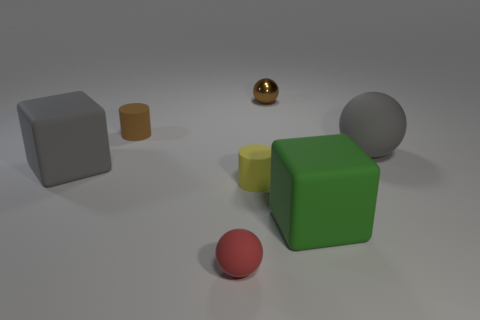Are there any other things that are made of the same material as the brown sphere?
Offer a very short reply. No. There is a tiny thing that is both behind the yellow rubber cylinder and on the right side of the brown cylinder; what material is it?
Your answer should be very brief. Metal. Is the color of the rubber block left of the small shiny sphere the same as the matte ball behind the small red sphere?
Your answer should be compact. Yes. How many other objects are the same size as the green rubber block?
Provide a short and direct response. 2. Is there a large gray matte object that is to the right of the large matte cube that is to the right of the large gray thing that is on the left side of the metal thing?
Ensure brevity in your answer.  Yes. Is the small cylinder in front of the gray rubber ball made of the same material as the large ball?
Offer a terse response. Yes. There is another small object that is the same shape as the tiny brown metal thing; what color is it?
Your answer should be very brief. Red. Are there an equal number of large rubber balls that are in front of the large green block and tiny brown shiny spheres?
Provide a short and direct response. No. There is a green rubber thing; are there any small brown cylinders behind it?
Offer a terse response. Yes. There is a brown thing that is on the left side of the tiny matte cylinder that is to the right of the tiny cylinder that is on the left side of the tiny yellow matte object; how big is it?
Your answer should be compact. Small. 